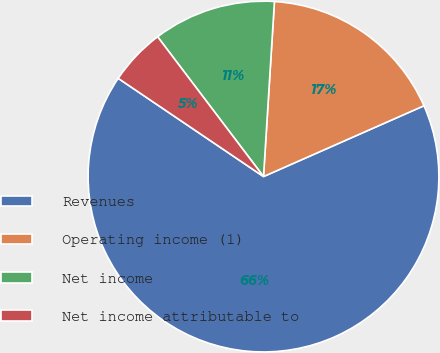Convert chart. <chart><loc_0><loc_0><loc_500><loc_500><pie_chart><fcel>Revenues<fcel>Operating income (1)<fcel>Net income<fcel>Net income attributable to<nl><fcel>66.07%<fcel>17.39%<fcel>11.31%<fcel>5.22%<nl></chart> 